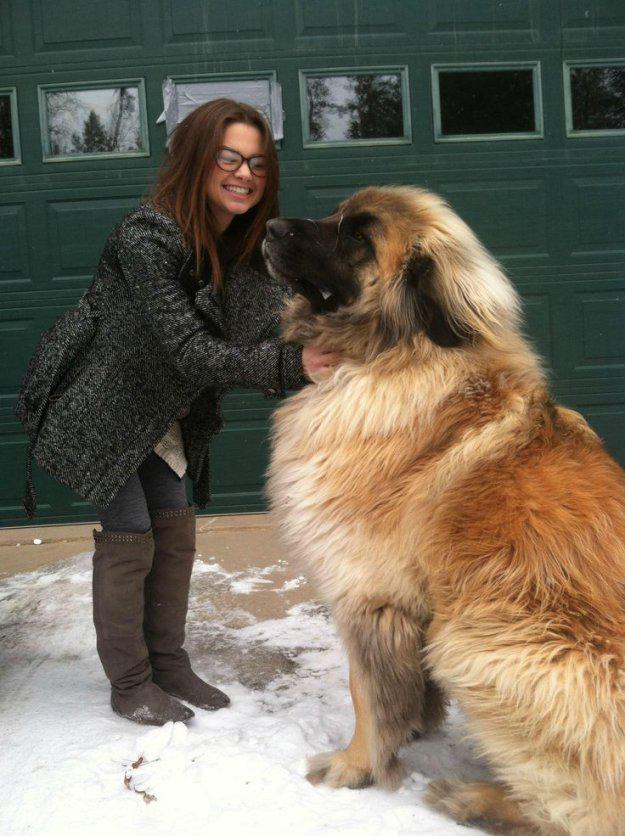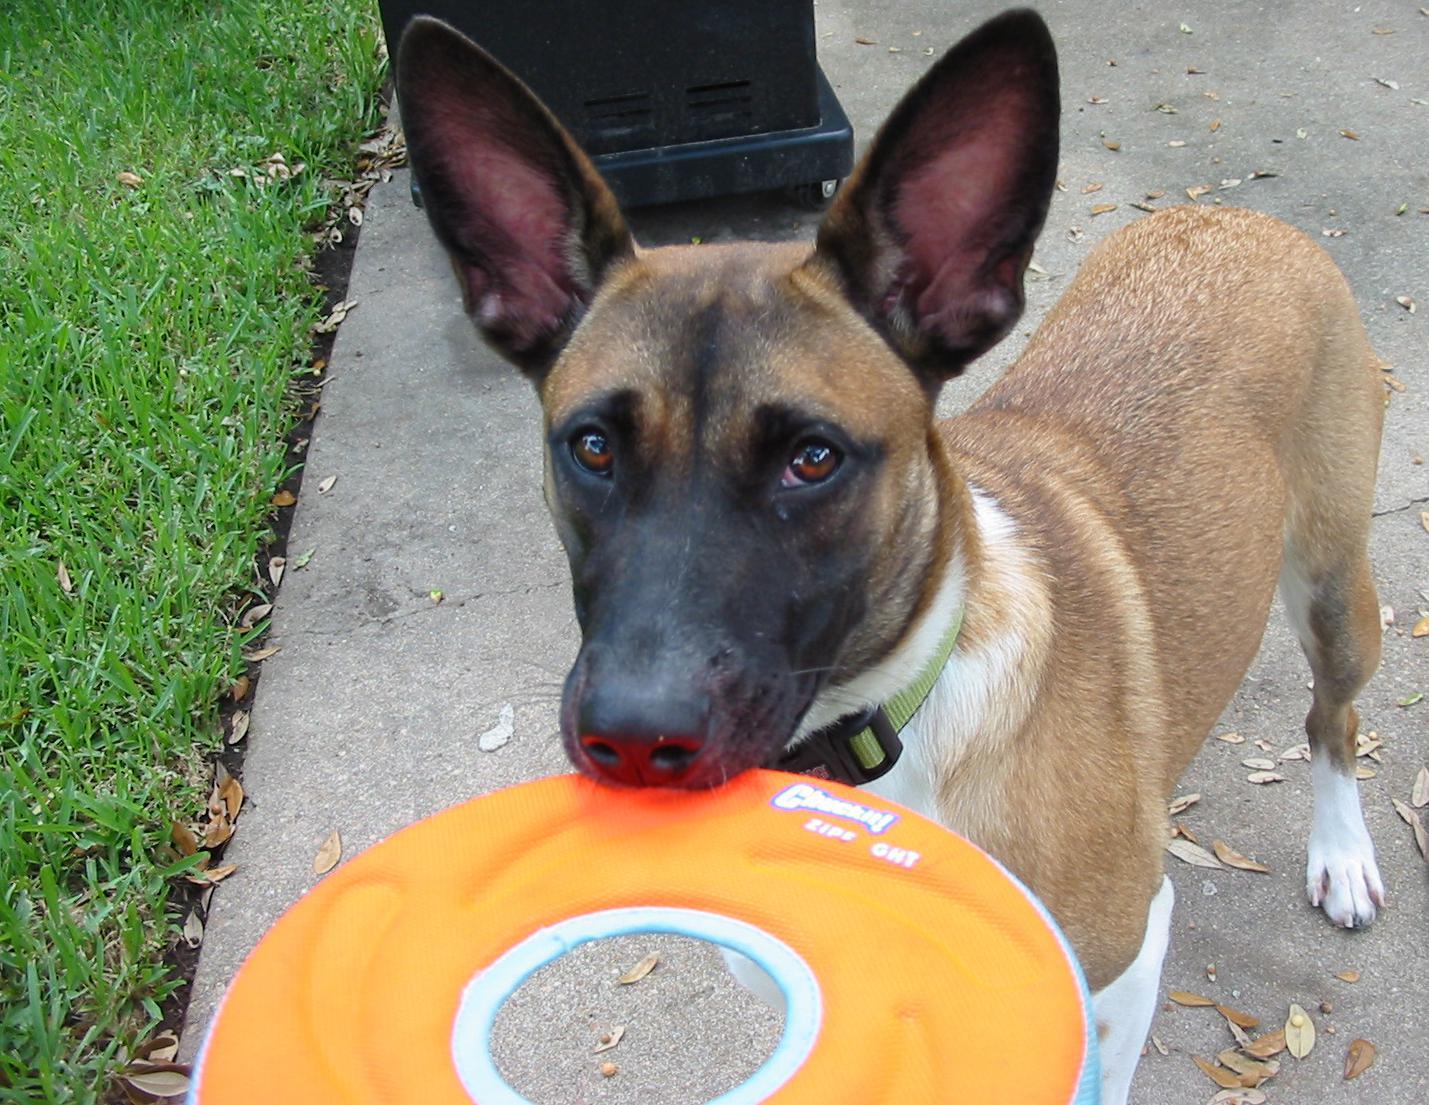The first image is the image on the left, the second image is the image on the right. For the images shown, is this caption "The left image contains one person standing to the left of a dog." true? Answer yes or no. Yes. The first image is the image on the left, the second image is the image on the right. Considering the images on both sides, is "An image shows a person at the left, interacting with one big dog." valid? Answer yes or no. Yes. 